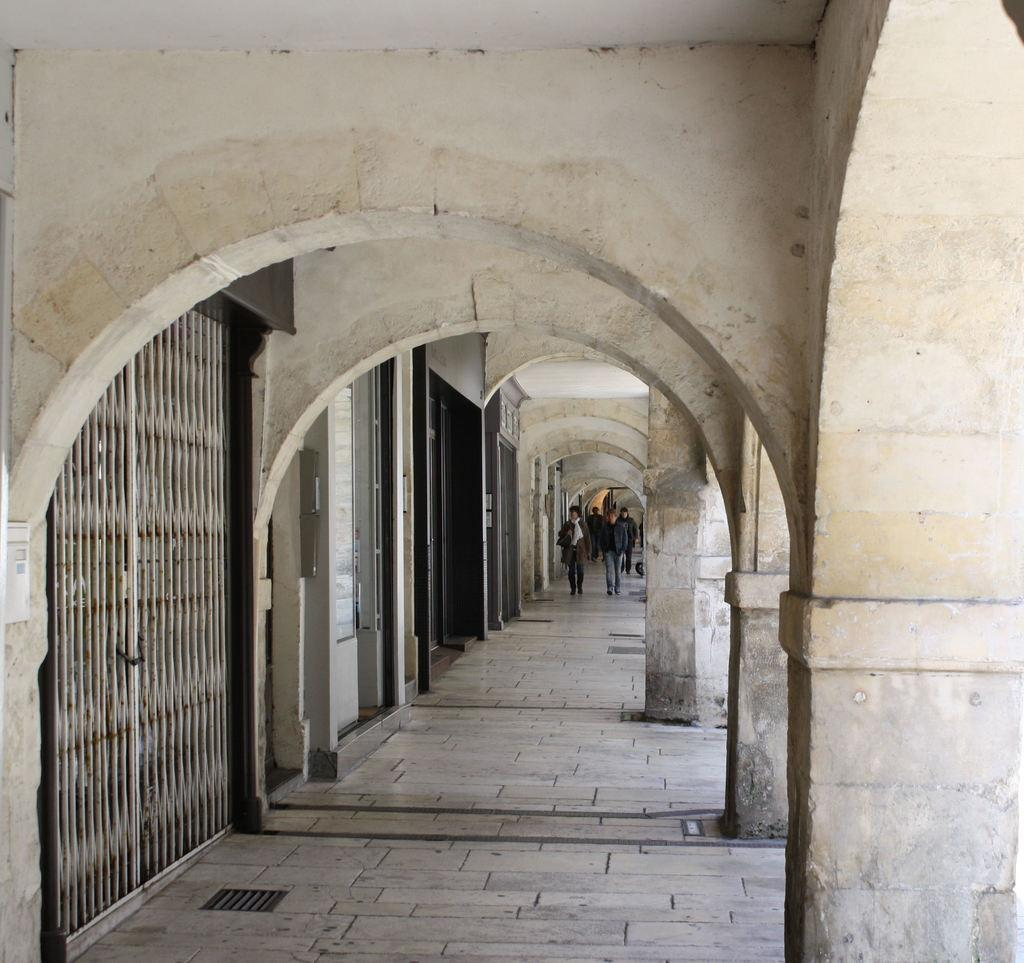What are the people in the image doing? The persons in the image are walking on the floor in the center of the image. What can be seen on the left side of the image? There are doors and gates on the left side of the image. What architectural features are present on the right side of the image? There are pillars on the right side of the image. What type of bulb is hanging from the collar of the person in the image? There is no bulb or collar present on any person in the image. Can you tell me how many wrens are perched on the pillars in the image? There are no wrens present in the image; only doors, gates, and pillars can be seen. 